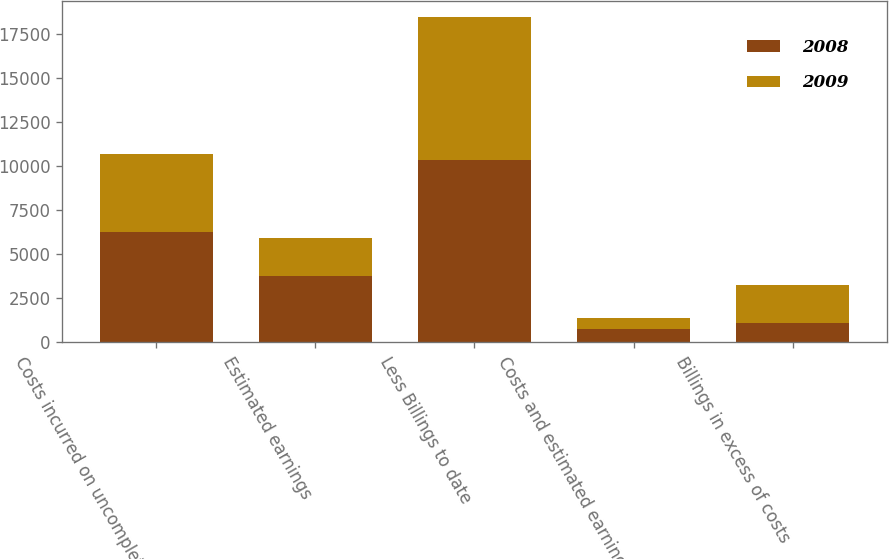Convert chart to OTSL. <chart><loc_0><loc_0><loc_500><loc_500><stacked_bar_chart><ecel><fcel>Costs incurred on uncompleted<fcel>Estimated earnings<fcel>Less Billings to date<fcel>Costs and estimated earnings<fcel>Billings in excess of costs<nl><fcel>2008<fcel>6276<fcel>3735<fcel>10361<fcel>740<fcel>1090<nl><fcel>2009<fcel>4397<fcel>2183<fcel>8123<fcel>618<fcel>2161<nl></chart> 